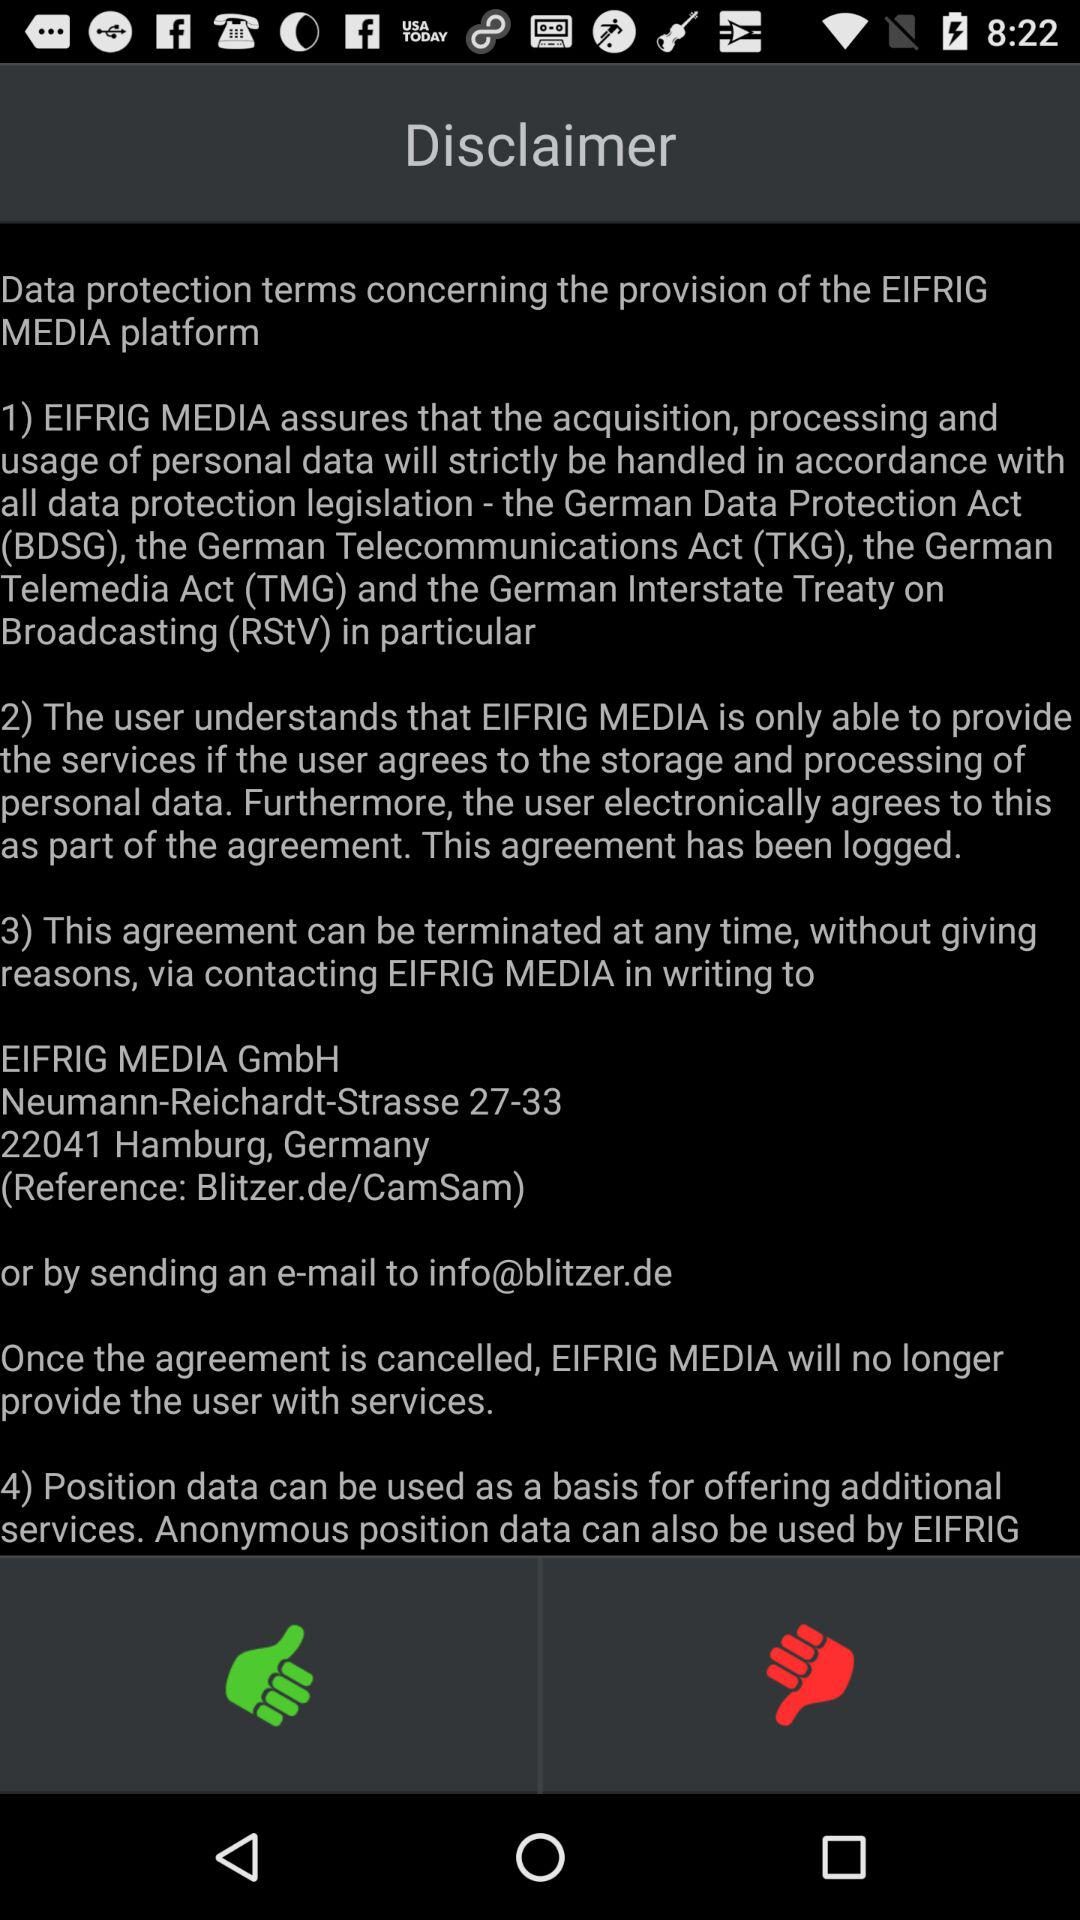How many sections are there in the data protection terms?
Answer the question using a single word or phrase. 4 